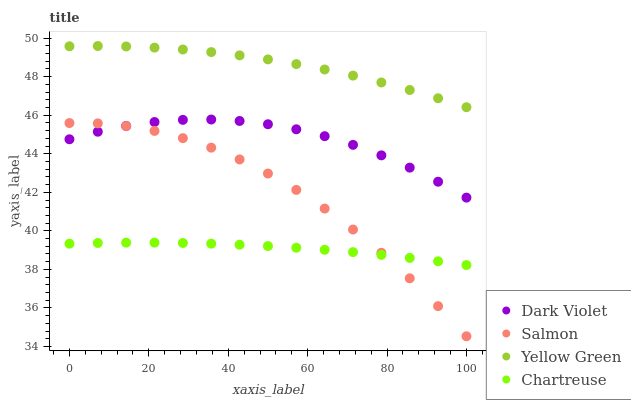Does Chartreuse have the minimum area under the curve?
Answer yes or no. Yes. Does Yellow Green have the maximum area under the curve?
Answer yes or no. Yes. Does Salmon have the minimum area under the curve?
Answer yes or no. No. Does Salmon have the maximum area under the curve?
Answer yes or no. No. Is Chartreuse the smoothest?
Answer yes or no. Yes. Is Salmon the roughest?
Answer yes or no. Yes. Is Yellow Green the smoothest?
Answer yes or no. No. Is Yellow Green the roughest?
Answer yes or no. No. Does Salmon have the lowest value?
Answer yes or no. Yes. Does Yellow Green have the lowest value?
Answer yes or no. No. Does Yellow Green have the highest value?
Answer yes or no. Yes. Does Salmon have the highest value?
Answer yes or no. No. Is Dark Violet less than Yellow Green?
Answer yes or no. Yes. Is Yellow Green greater than Chartreuse?
Answer yes or no. Yes. Does Dark Violet intersect Salmon?
Answer yes or no. Yes. Is Dark Violet less than Salmon?
Answer yes or no. No. Is Dark Violet greater than Salmon?
Answer yes or no. No. Does Dark Violet intersect Yellow Green?
Answer yes or no. No. 